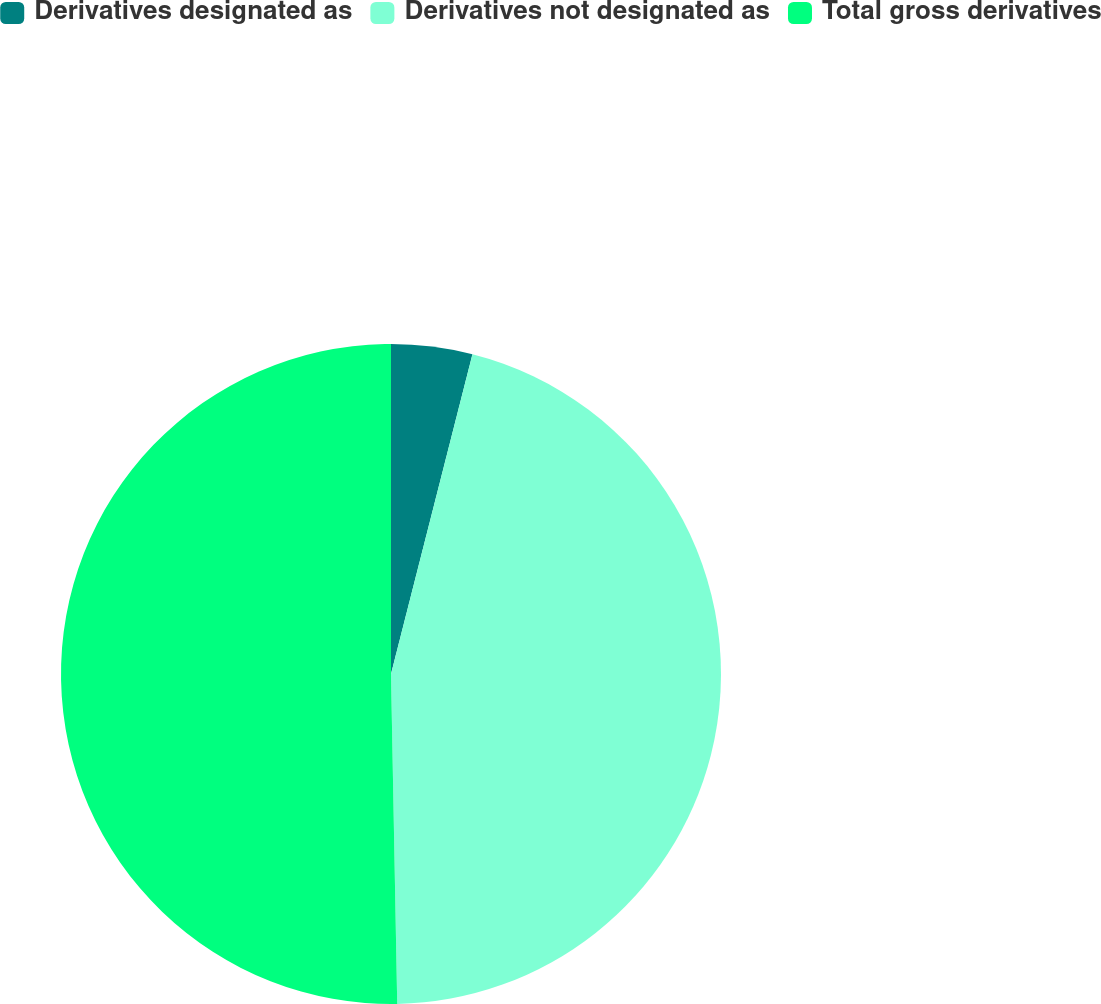<chart> <loc_0><loc_0><loc_500><loc_500><pie_chart><fcel>Derivatives designated as<fcel>Derivatives not designated as<fcel>Total gross derivatives<nl><fcel>3.97%<fcel>45.73%<fcel>50.3%<nl></chart> 